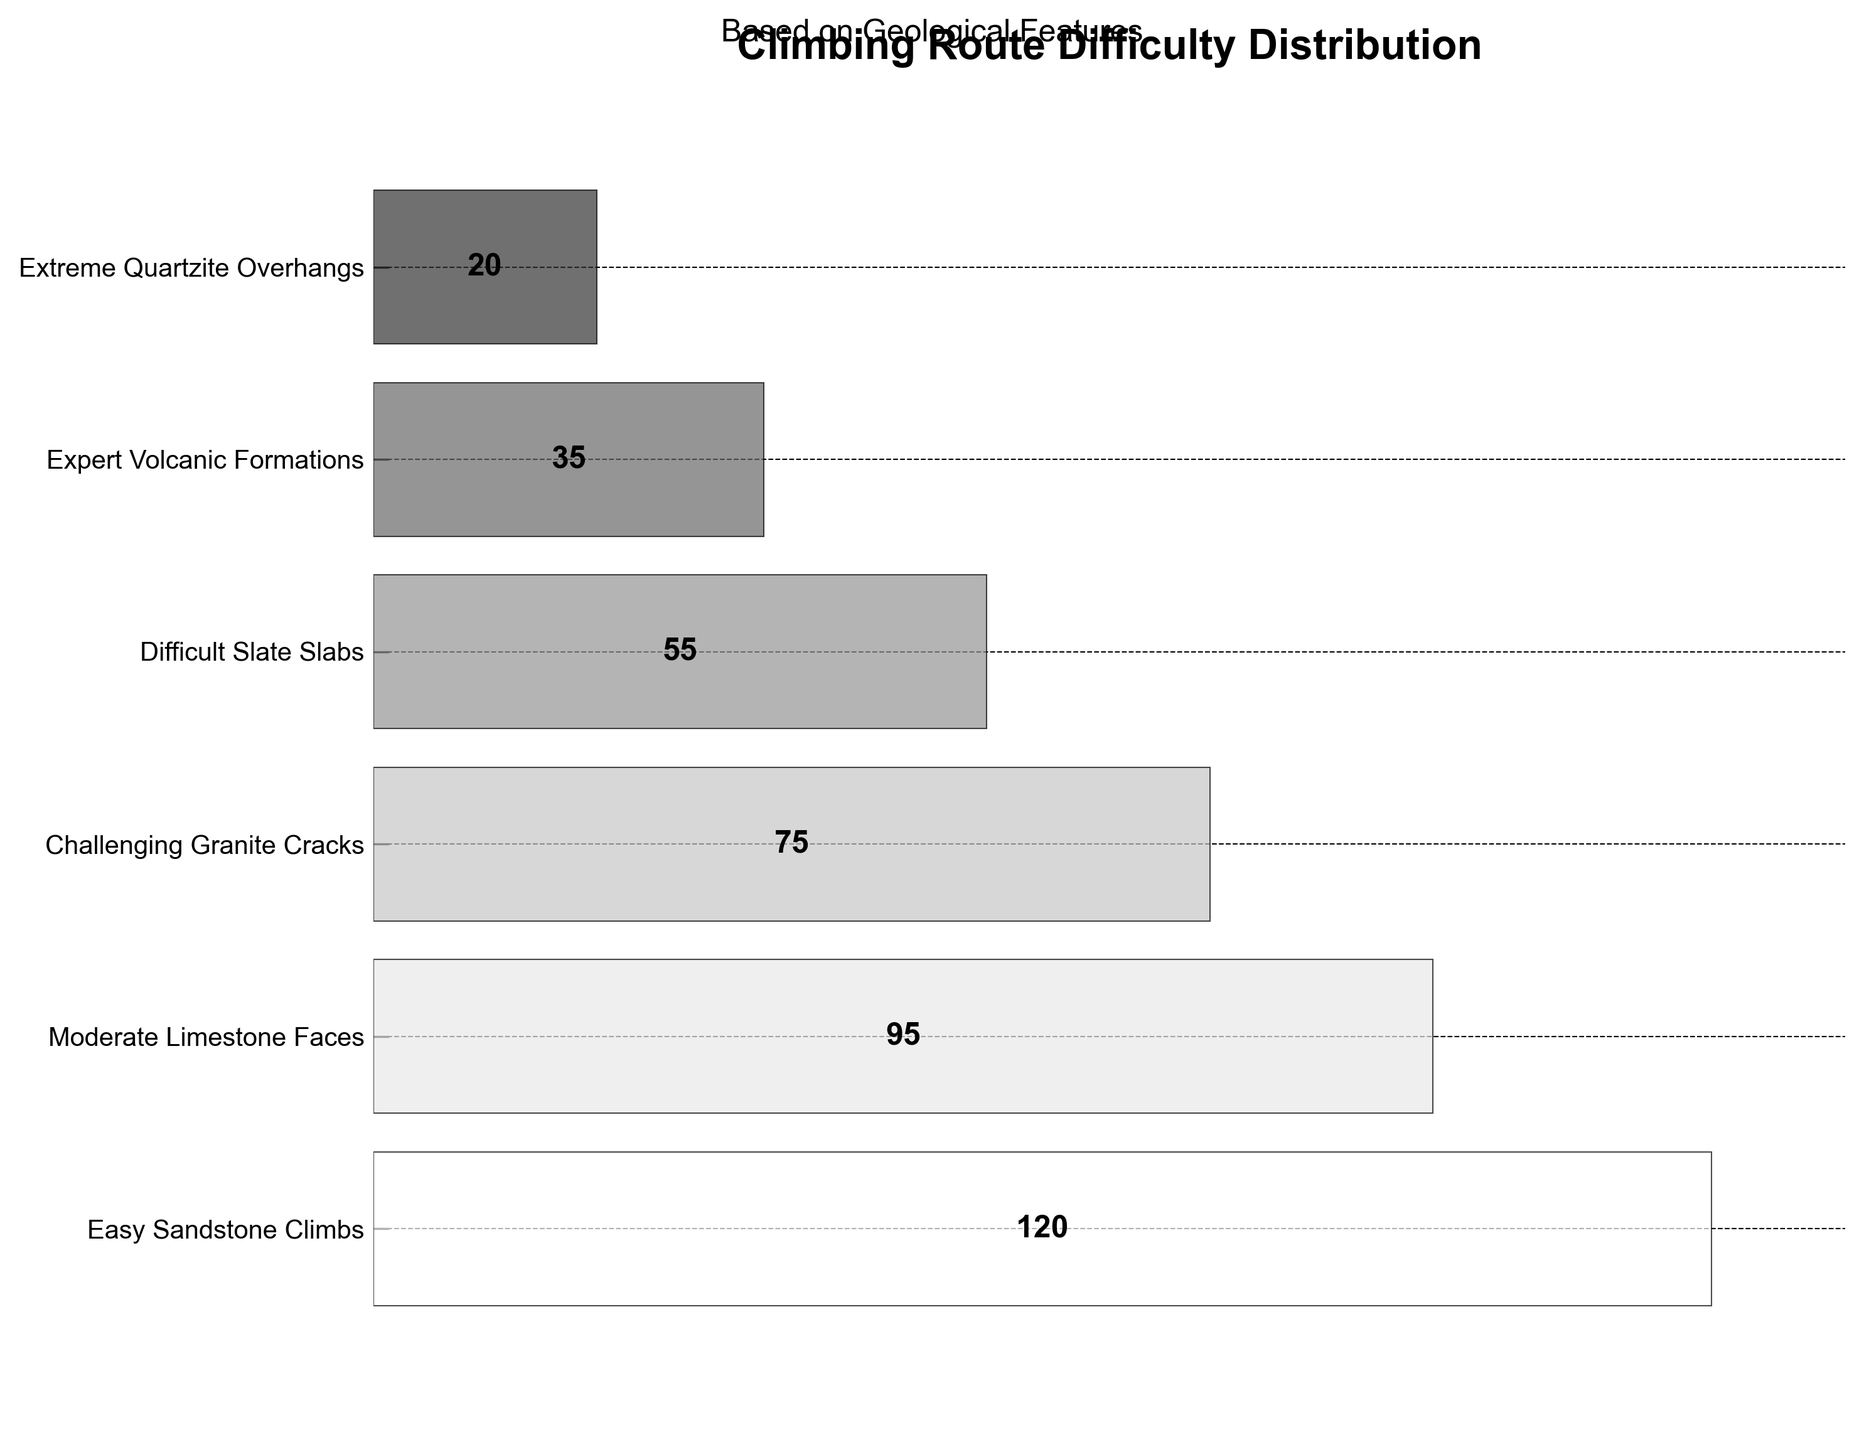What's the title of the figure? The title is usually located at the top part of the figure. In this figure, the title is written in bold letters.
Answer: Climbing Route Difficulty Distribution How many climbing routes are represented in the chart? By counting the number of distinct route types listed on the y-axis, we can determine the number of climbing routes represented in the chart.
Answer: 6 Which type of climbing route has the highest number of routes? By inspecting the width of the polygons, the widest polygon corresponds to the highest number, and the label next to it identifies the route type.
Answer: Easy Sandstone Climbs How many more Moderate Limestone Faces routes are there compared to Extreme Quartzite Overhangs routes? Subtract the number of Extreme Quartzite Overhangs routes from the number of Moderate Limestone Faces routes (95 - 20).
Answer: 75 Which type of climbing route has the smallest number of routes? By observing the figure, the narrowest polygon corresponds to the smallest number of routes, and the label next to it identifies the route type.
Answer: Extreme Quartzite Overhangs What's the total number of climbing routes shown in the figure? Sum the numbers of all the route types: (120 + 95 + 75 + 55 + 35 + 20).
Answer: 400 Which type of climbing route is slightly less common than the Challenging Granite Cracks route? The polygon representing the next smaller width after Challenging Granite Cracks (75 routes) is the Difficult Slate Slabs (55 routes).
Answer: Difficult Slate Slabs Calculate the average number of routes per climbing difficulty level. First, find the total number of routes (400). Then, divide this by the number of route types (6).
Answer: 66.67 Do Expert Volcanic Formations have more or fewer routes than Challenging Granite Cracks? Compare the numbers: Expert Volcanic Formations (35) and Challenging Granite Cracks (75).
Answer: Fewer Roughly what percentage of the total routes are the Easy Sandstone Climbs? Calculate by dividing the number of Easy Sandstone Climbs (120) by the total number of routes (400) and multiply by 100. (120/400) * 100.
Answer: 30% 